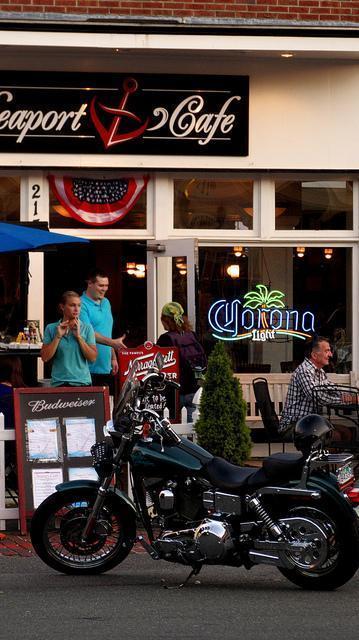How many motorcycles are pictured?
Give a very brief answer. 1. How many people are visible?
Give a very brief answer. 4. How many blue truck cabs are there?
Give a very brief answer. 0. 